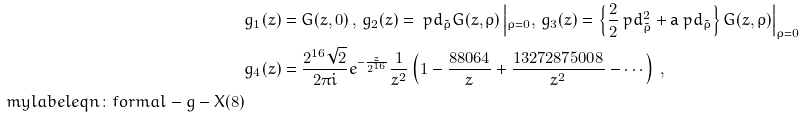<formula> <loc_0><loc_0><loc_500><loc_500>& g _ { 1 } ( z ) = G ( z , 0 ) \, , \, g _ { 2 } ( z ) = \ p d _ { \tilde { \rho } } G ( z , \rho ) \left | _ { \rho = 0 } , \, g _ { 3 } ( z ) = \left \{ \frac { 2 } { 2 } \ p d _ { \tilde { \rho } } ^ { 2 } + { \tt a } \ p d _ { \tilde { \rho } } \right \} G ( z , \rho ) \right | _ { \rho = 0 } \\ & g _ { 4 } ( z ) = \frac { 2 ^ { 1 6 } \sqrt { 2 } } { 2 \pi i } e ^ { - \frac { z } { 2 ^ { 1 6 } } } \frac { 1 } { z ^ { 2 } } \left ( 1 - \frac { 8 8 0 6 4 } { z } + \frac { 1 3 2 7 2 8 7 5 0 0 8 } { z ^ { 2 } } - \cdots \right ) \, , \\ \ m y l a b e l { e q n \colon f o r m a l - g - X ( 8 ) }</formula> 